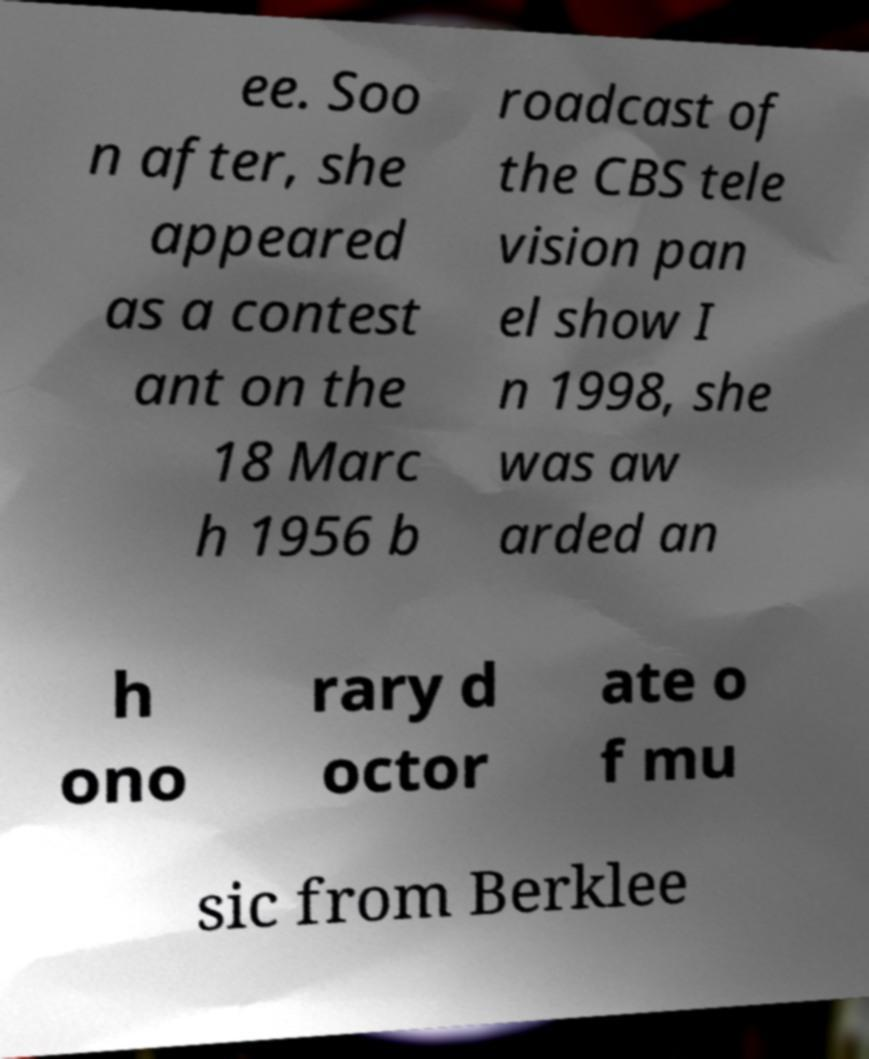Can you read and provide the text displayed in the image?This photo seems to have some interesting text. Can you extract and type it out for me? ee. Soo n after, she appeared as a contest ant on the 18 Marc h 1956 b roadcast of the CBS tele vision pan el show I n 1998, she was aw arded an h ono rary d octor ate o f mu sic from Berklee 